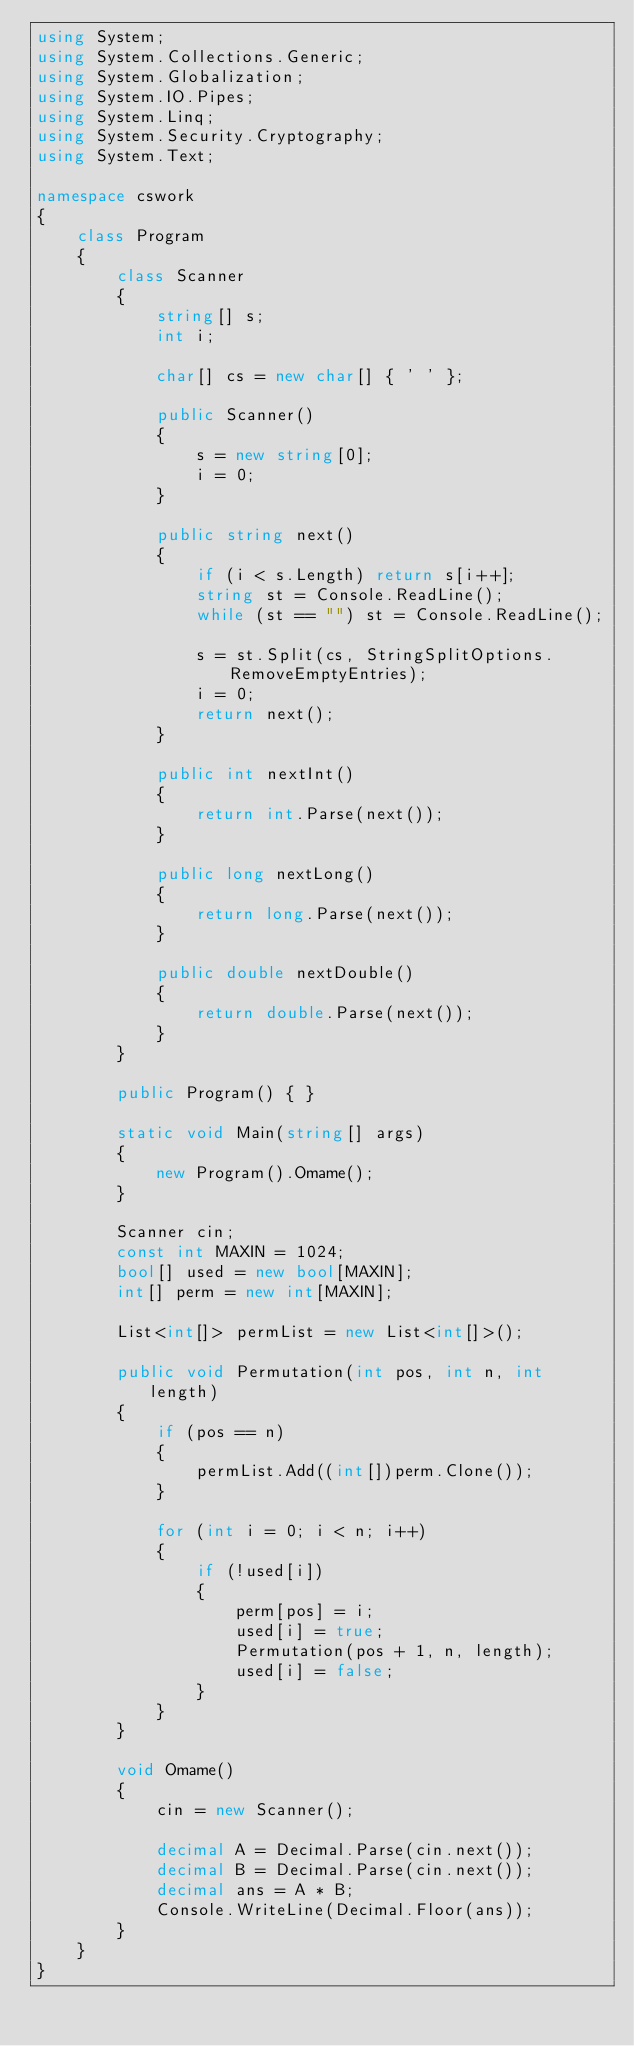<code> <loc_0><loc_0><loc_500><loc_500><_C#_>using System;
using System.Collections.Generic;
using System.Globalization;
using System.IO.Pipes;
using System.Linq;
using System.Security.Cryptography;
using System.Text;

namespace cswork
{
    class Program
    {
        class Scanner
        {
            string[] s;
            int i;

            char[] cs = new char[] { ' ' };

            public Scanner()
            {
                s = new string[0];
                i = 0;
            }

            public string next()
            {
                if (i < s.Length) return s[i++];
                string st = Console.ReadLine();
                while (st == "") st = Console.ReadLine();

                s = st.Split(cs, StringSplitOptions.RemoveEmptyEntries);
                i = 0;
                return next();
            }

            public int nextInt()
            {
                return int.Parse(next());
            }

            public long nextLong()
            {
                return long.Parse(next());
            }

            public double nextDouble()
            {
                return double.Parse(next());
            }
        }

        public Program() { }

        static void Main(string[] args)
        {
            new Program().Omame();
        }

        Scanner cin;
        const int MAXIN = 1024;
        bool[] used = new bool[MAXIN];
        int[] perm = new int[MAXIN];

        List<int[]> permList = new List<int[]>();

        public void Permutation(int pos, int n, int length)
        {
            if (pos == n)
            {
                permList.Add((int[])perm.Clone());
            }

            for (int i = 0; i < n; i++)
            {
                if (!used[i])
                {
                    perm[pos] = i;
                    used[i] = true;
                    Permutation(pos + 1, n, length);
                    used[i] = false;
                }
            }
        }

        void Omame()
        {
            cin = new Scanner();

            decimal A = Decimal.Parse(cin.next());
            decimal B = Decimal.Parse(cin.next());
            decimal ans = A * B;
            Console.WriteLine(Decimal.Floor(ans));
        }
    }
}
</code> 